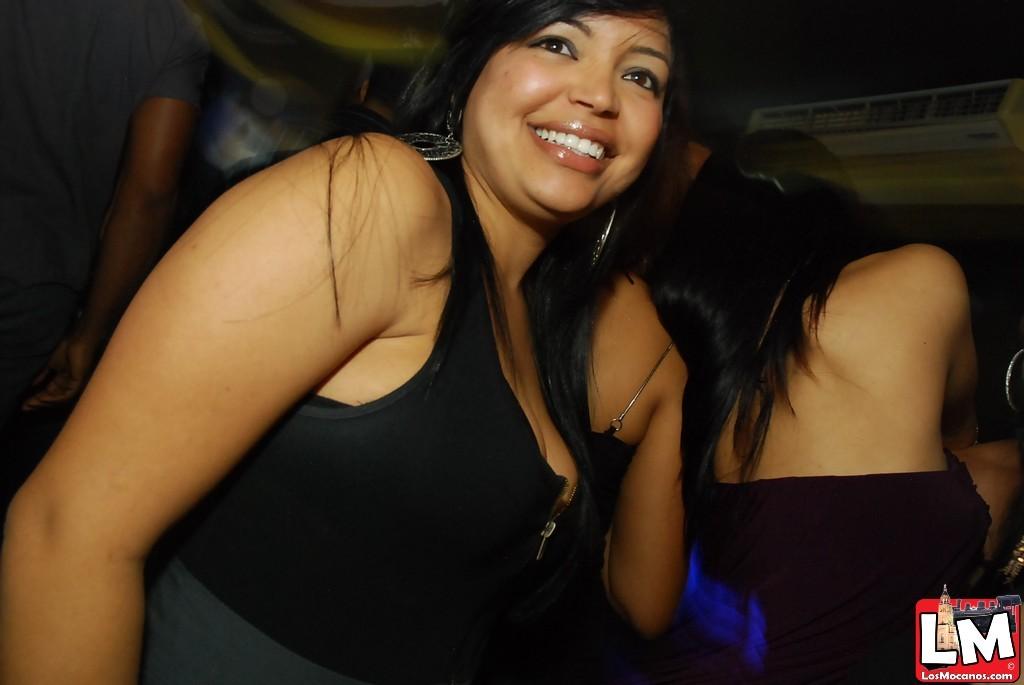What is the name of the website streaming this video?
Make the answer very short. Lm. What 2 letters are written in the icon in the bottom right?
Your answer should be compact. Lm. 